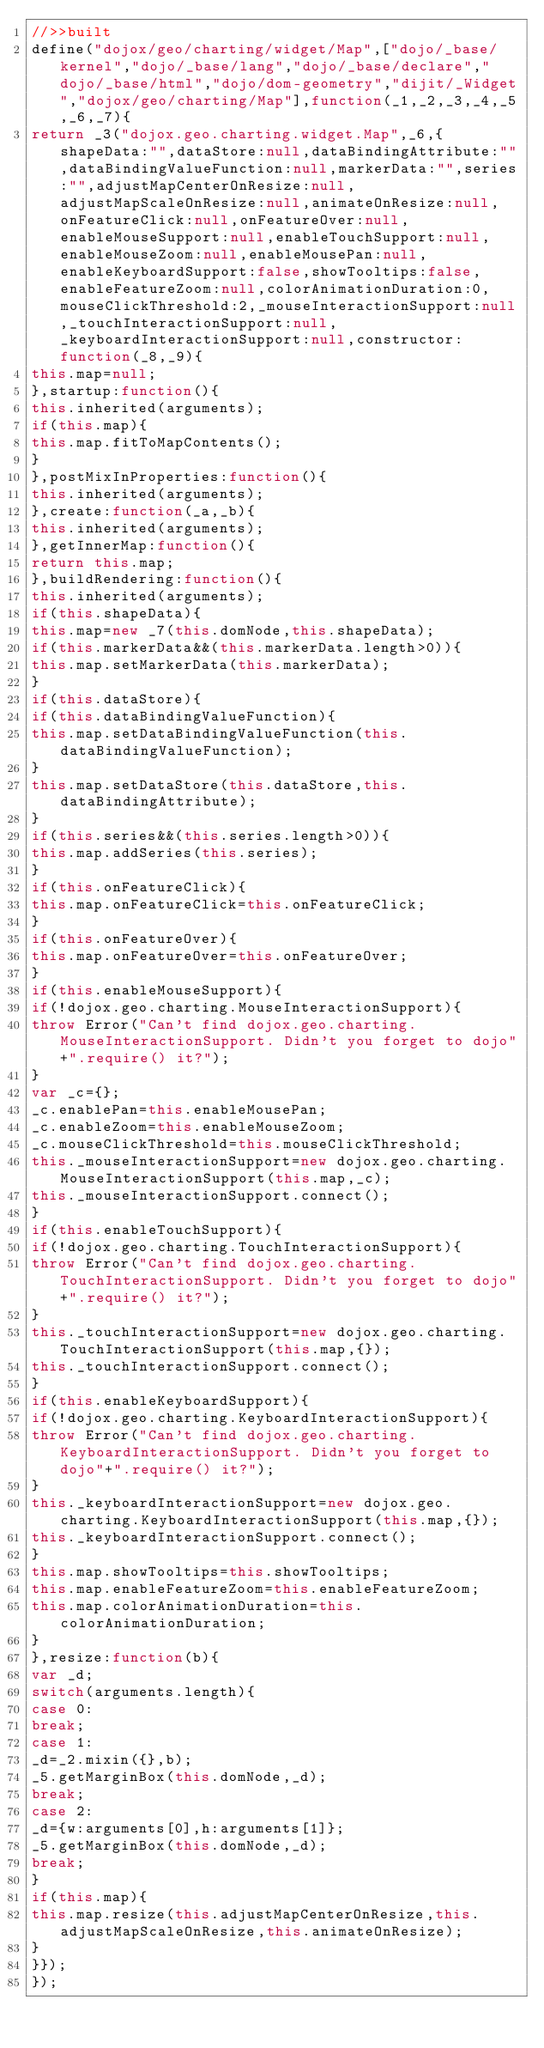<code> <loc_0><loc_0><loc_500><loc_500><_JavaScript_>//>>built
define("dojox/geo/charting/widget/Map",["dojo/_base/kernel","dojo/_base/lang","dojo/_base/declare","dojo/_base/html","dojo/dom-geometry","dijit/_Widget","dojox/geo/charting/Map"],function(_1,_2,_3,_4,_5,_6,_7){
return _3("dojox.geo.charting.widget.Map",_6,{shapeData:"",dataStore:null,dataBindingAttribute:"",dataBindingValueFunction:null,markerData:"",series:"",adjustMapCenterOnResize:null,adjustMapScaleOnResize:null,animateOnResize:null,onFeatureClick:null,onFeatureOver:null,enableMouseSupport:null,enableTouchSupport:null,enableMouseZoom:null,enableMousePan:null,enableKeyboardSupport:false,showTooltips:false,enableFeatureZoom:null,colorAnimationDuration:0,mouseClickThreshold:2,_mouseInteractionSupport:null,_touchInteractionSupport:null,_keyboardInteractionSupport:null,constructor:function(_8,_9){
this.map=null;
},startup:function(){
this.inherited(arguments);
if(this.map){
this.map.fitToMapContents();
}
},postMixInProperties:function(){
this.inherited(arguments);
},create:function(_a,_b){
this.inherited(arguments);
},getInnerMap:function(){
return this.map;
},buildRendering:function(){
this.inherited(arguments);
if(this.shapeData){
this.map=new _7(this.domNode,this.shapeData);
if(this.markerData&&(this.markerData.length>0)){
this.map.setMarkerData(this.markerData);
}
if(this.dataStore){
if(this.dataBindingValueFunction){
this.map.setDataBindingValueFunction(this.dataBindingValueFunction);
}
this.map.setDataStore(this.dataStore,this.dataBindingAttribute);
}
if(this.series&&(this.series.length>0)){
this.map.addSeries(this.series);
}
if(this.onFeatureClick){
this.map.onFeatureClick=this.onFeatureClick;
}
if(this.onFeatureOver){
this.map.onFeatureOver=this.onFeatureOver;
}
if(this.enableMouseSupport){
if(!dojox.geo.charting.MouseInteractionSupport){
throw Error("Can't find dojox.geo.charting.MouseInteractionSupport. Didn't you forget to dojo"+".require() it?");
}
var _c={};
_c.enablePan=this.enableMousePan;
_c.enableZoom=this.enableMouseZoom;
_c.mouseClickThreshold=this.mouseClickThreshold;
this._mouseInteractionSupport=new dojox.geo.charting.MouseInteractionSupport(this.map,_c);
this._mouseInteractionSupport.connect();
}
if(this.enableTouchSupport){
if(!dojox.geo.charting.TouchInteractionSupport){
throw Error("Can't find dojox.geo.charting.TouchInteractionSupport. Didn't you forget to dojo"+".require() it?");
}
this._touchInteractionSupport=new dojox.geo.charting.TouchInteractionSupport(this.map,{});
this._touchInteractionSupport.connect();
}
if(this.enableKeyboardSupport){
if(!dojox.geo.charting.KeyboardInteractionSupport){
throw Error("Can't find dojox.geo.charting.KeyboardInteractionSupport. Didn't you forget to dojo"+".require() it?");
}
this._keyboardInteractionSupport=new dojox.geo.charting.KeyboardInteractionSupport(this.map,{});
this._keyboardInteractionSupport.connect();
}
this.map.showTooltips=this.showTooltips;
this.map.enableFeatureZoom=this.enableFeatureZoom;
this.map.colorAnimationDuration=this.colorAnimationDuration;
}
},resize:function(b){
var _d;
switch(arguments.length){
case 0:
break;
case 1:
_d=_2.mixin({},b);
_5.getMarginBox(this.domNode,_d);
break;
case 2:
_d={w:arguments[0],h:arguments[1]};
_5.getMarginBox(this.domNode,_d);
break;
}
if(this.map){
this.map.resize(this.adjustMapCenterOnResize,this.adjustMapScaleOnResize,this.animateOnResize);
}
}});
});
 </code> 